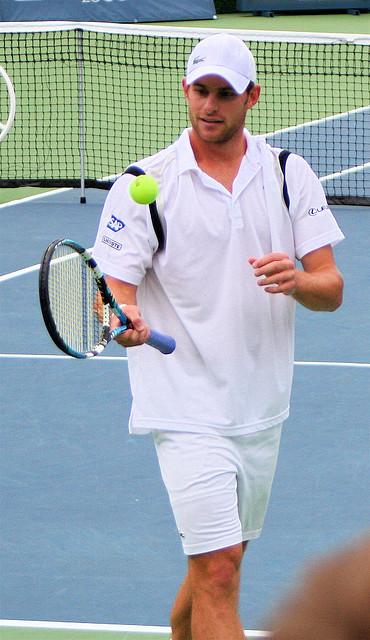Does the man have facial hair?
Concise answer only. Yes. What sport is this?
Answer briefly. Tennis. Is the man sweaty?
Answer briefly. No. Who is this man?
Give a very brief answer. Tennis player. 